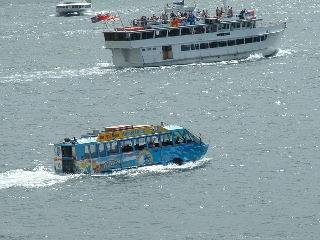Can you describe the setting and environment in which these boats are operating? Certainly, the setting is a large body of water with a bustling maritime environment. The water has some ripples and waves, indicating a light breeze. It's a clear day with good visibility, ideal for boating activities. The context suggests a popular waterway, possibly near a city or tourist destination, where commercial and recreational boating coexist. 